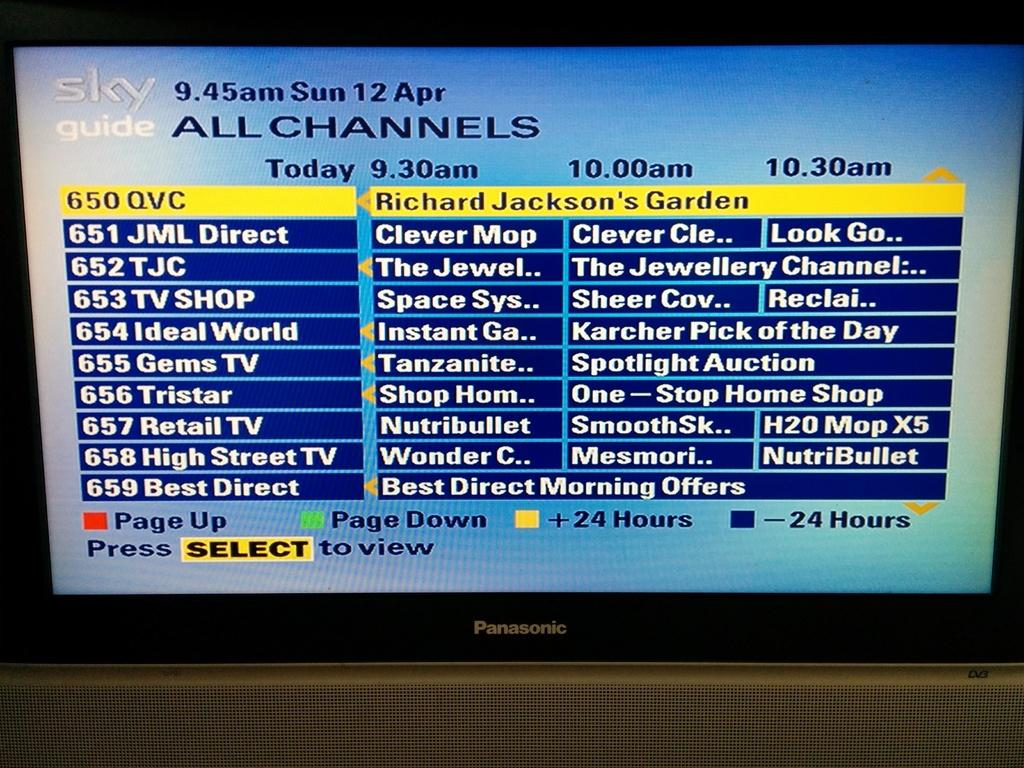<image>
Give a short and clear explanation of the subsequent image. the Sky guide is showing what is on each channel 